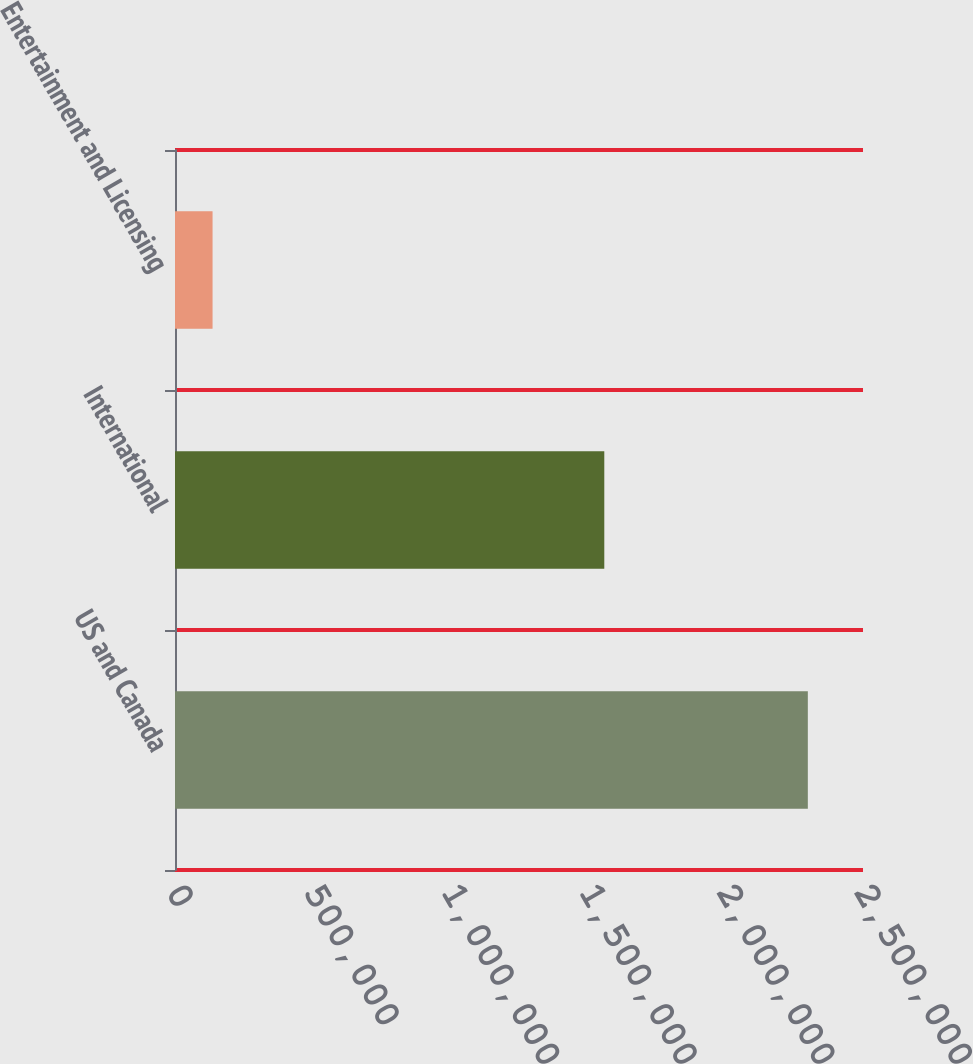Convert chart to OTSL. <chart><loc_0><loc_0><loc_500><loc_500><bar_chart><fcel>US and Canada<fcel>International<fcel>Entertainment and Licensing<nl><fcel>2.29955e+06<fcel>1.55993e+06<fcel>136488<nl></chart> 